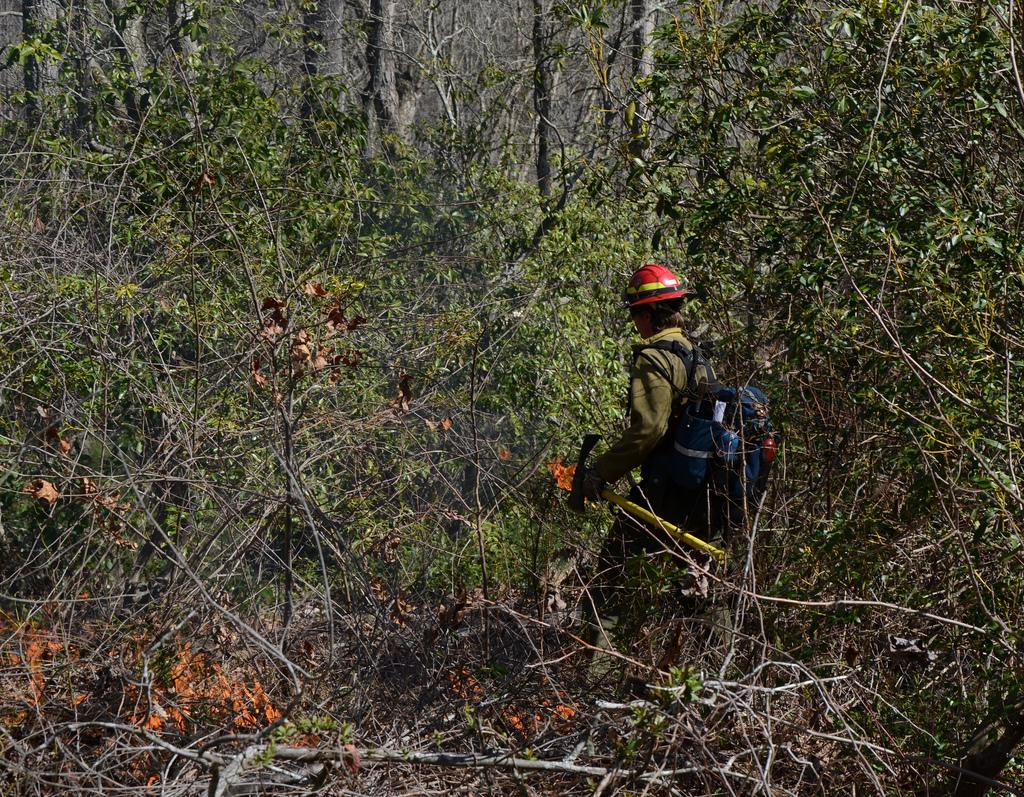What can be seen in the image? There is a person in the image. What is the person wearing? The person is wearing a green color uniform and a red color helmet. What type of bag does the person have? The person has a black color bag. What is visible in the background of the image? The background of the image includes trees. What is the color of the trees in the background? The trees in the background are green in color. What type of noise does the person make in the image? There is no indication of any noise made by the person in the image. 